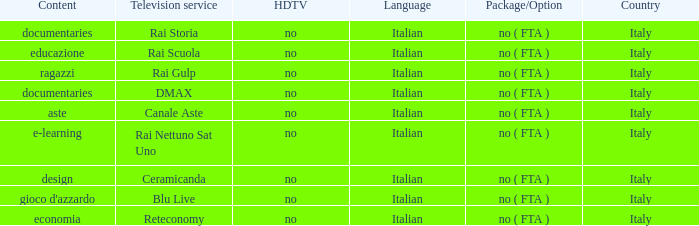What is the Country with Reteconomy as the Television service? Italy. Write the full table. {'header': ['Content', 'Television service', 'HDTV', 'Language', 'Package/Option', 'Country'], 'rows': [['documentaries', 'Rai Storia', 'no', 'Italian', 'no ( FTA )', 'Italy'], ['educazione', 'Rai Scuola', 'no', 'Italian', 'no ( FTA )', 'Italy'], ['ragazzi', 'Rai Gulp', 'no', 'Italian', 'no ( FTA )', 'Italy'], ['documentaries', 'DMAX', 'no', 'Italian', 'no ( FTA )', 'Italy'], ['aste', 'Canale Aste', 'no', 'Italian', 'no ( FTA )', 'Italy'], ['e-learning', 'Rai Nettuno Sat Uno', 'no', 'Italian', 'no ( FTA )', 'Italy'], ['design', 'Ceramicanda', 'no', 'Italian', 'no ( FTA )', 'Italy'], ["gioco d'azzardo", 'Blu Live', 'no', 'Italian', 'no ( FTA )', 'Italy'], ['economia', 'Reteconomy', 'no', 'Italian', 'no ( FTA )', 'Italy']]} 